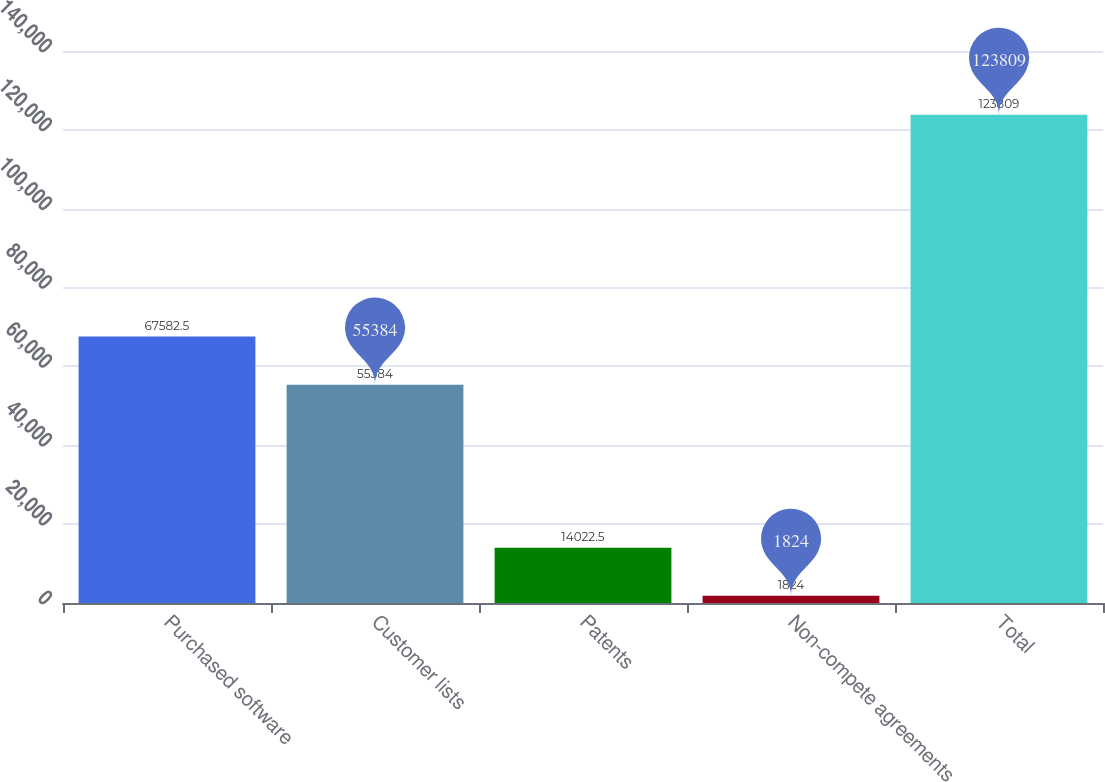<chart> <loc_0><loc_0><loc_500><loc_500><bar_chart><fcel>Purchased software<fcel>Customer lists<fcel>Patents<fcel>Non-compete agreements<fcel>Total<nl><fcel>67582.5<fcel>55384<fcel>14022.5<fcel>1824<fcel>123809<nl></chart> 